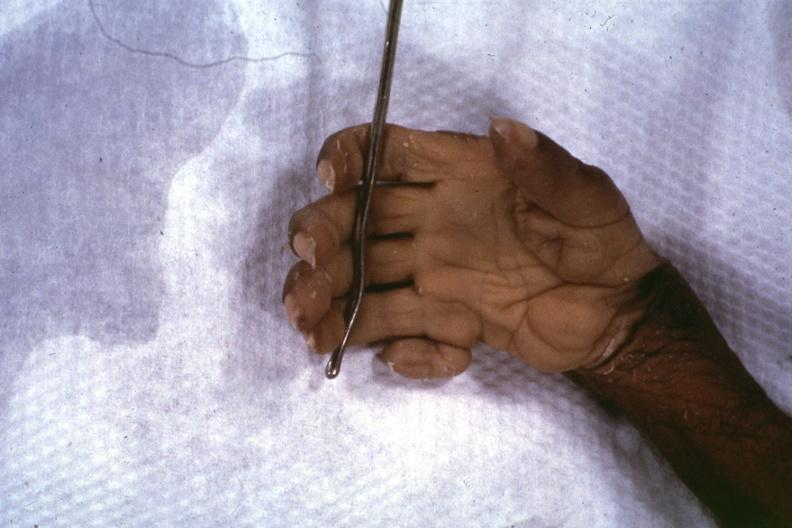what are present?
Answer the question using a single word or phrase. No 